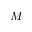<formula> <loc_0><loc_0><loc_500><loc_500>M</formula> 